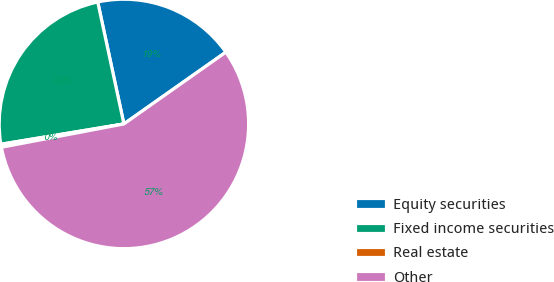<chart> <loc_0><loc_0><loc_500><loc_500><pie_chart><fcel>Equity securities<fcel>Fixed income securities<fcel>Real estate<fcel>Other<nl><fcel>18.6%<fcel>24.24%<fcel>0.39%<fcel>56.77%<nl></chart> 